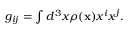<formula> <loc_0><loc_0><loc_500><loc_500>\begin{array} { r } { g _ { i j } = \int d ^ { 3 } x \rho ( { x } ) x ^ { i } x ^ { j } . } \end{array}</formula> 